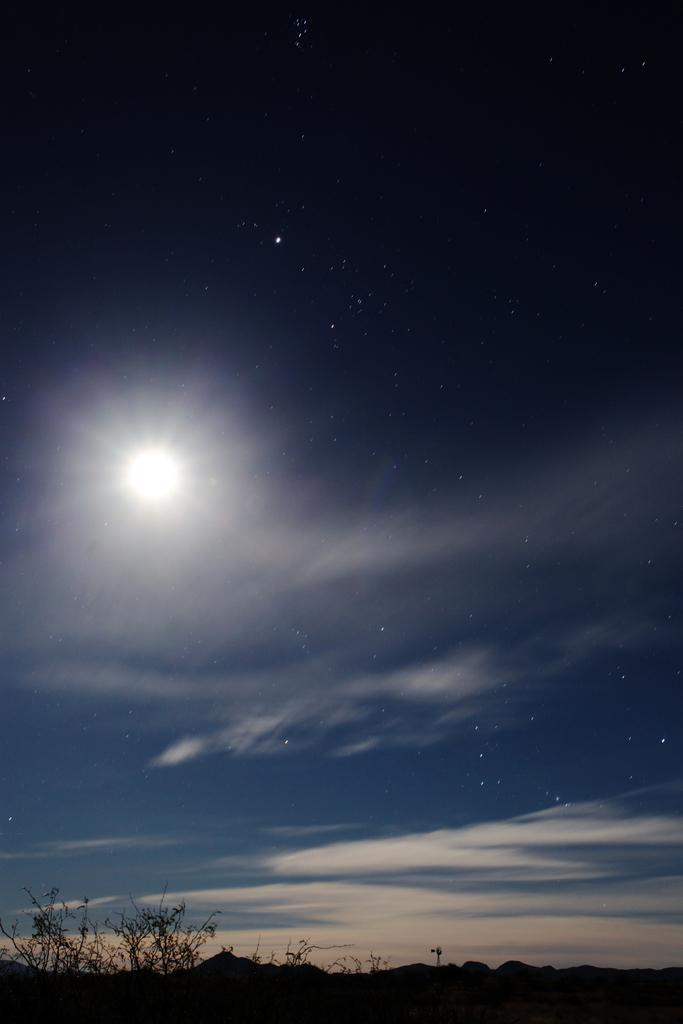Could you give a brief overview of what you see in this image? Here in this picture on the ground we can see grass and plants present and in the sky we can see clouds, stars and a moon present. 